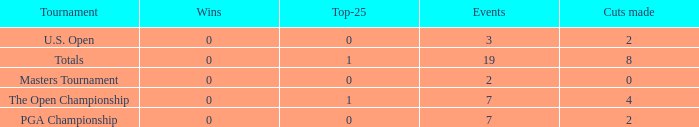What is the Wins of the Top-25 of 1 and 7 Events? 0.0. 